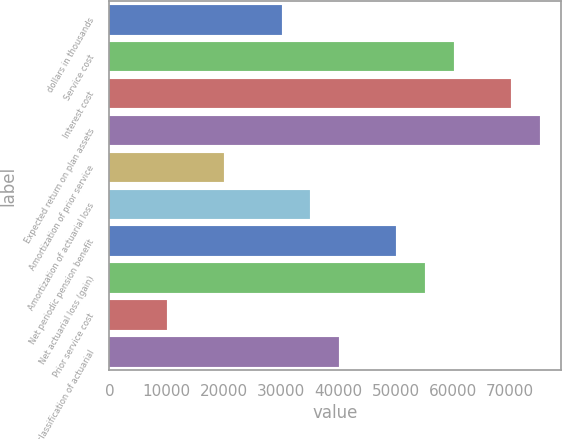<chart> <loc_0><loc_0><loc_500><loc_500><bar_chart><fcel>dollars in thousands<fcel>Service cost<fcel>Interest cost<fcel>Expected return on plan assets<fcel>Amortization of prior service<fcel>Amortization of actuarial loss<fcel>Net periodic pension benefit<fcel>Net actuarial loss (gain)<fcel>Prior service cost<fcel>Reclassification of actuarial<nl><fcel>30074.6<fcel>60145.7<fcel>70169.4<fcel>75181.3<fcel>20050.8<fcel>35086.4<fcel>50122<fcel>55133.9<fcel>10027.1<fcel>40098.3<nl></chart> 